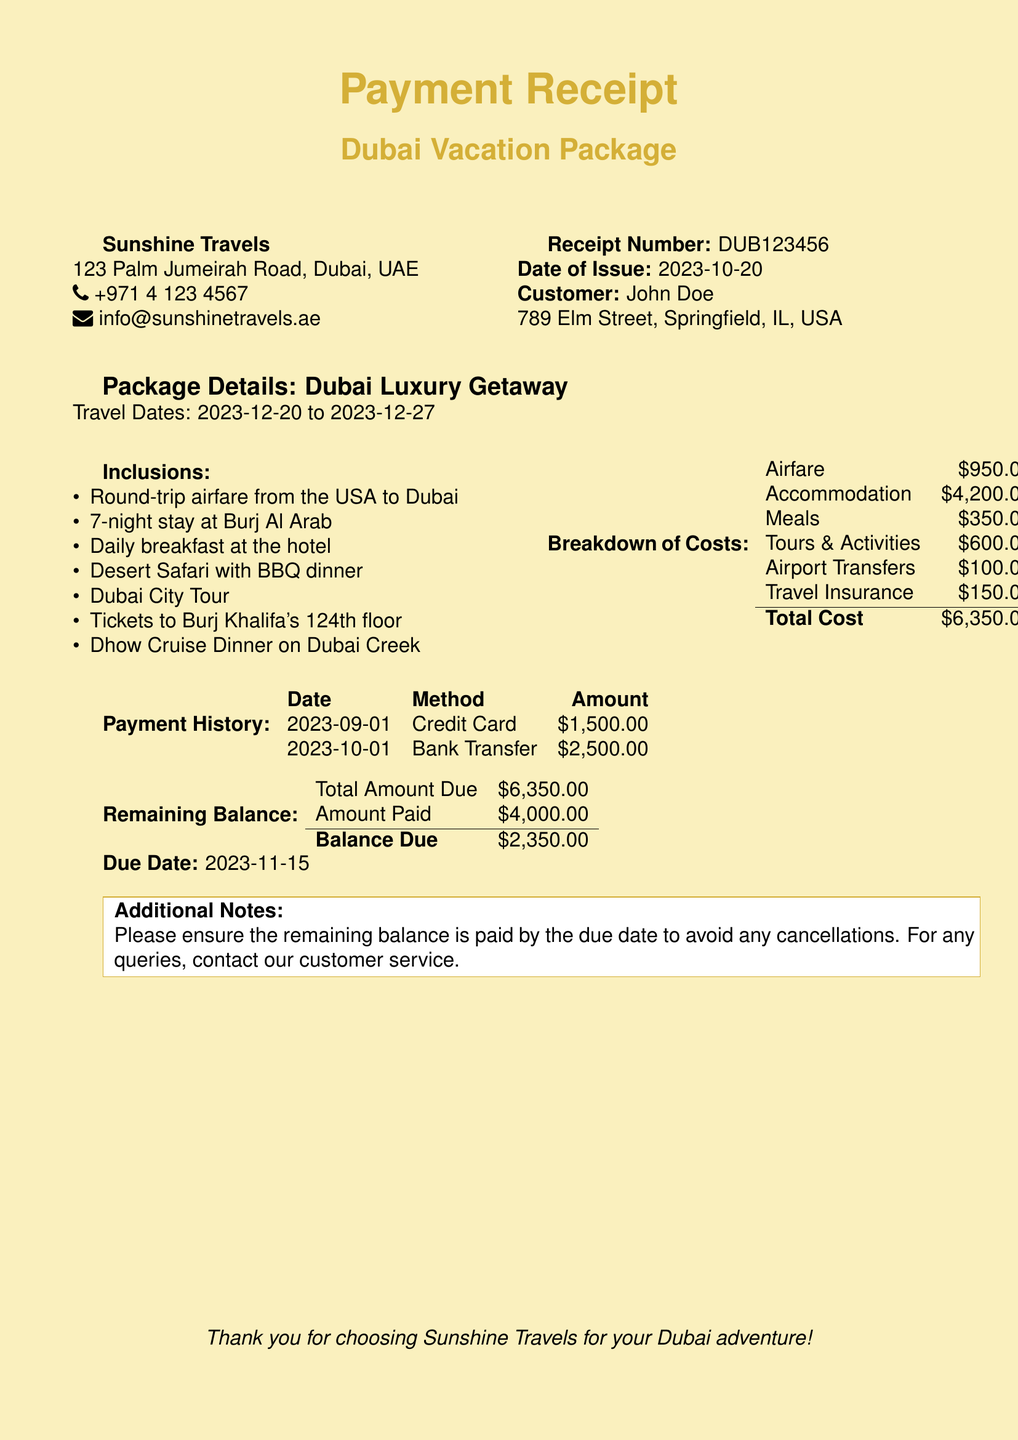What is the receipt number? The receipt number is listed in the document for tracking purposes, which is DUB123456.
Answer: DUB123456 What is the travel date range? The travel dates are specified in the package details, which shows the trip is from 2023-12-20 to 2023-12-27.
Answer: 2023-12-20 to 2023-12-27 What is the total cost of the vacation package? The total cost is summarized in the breakdown of costs section, which sums up to $6,350.00.
Answer: $6,350.00 How much has been paid so far? The payment history lists the amounts that have been paid, which totals $4,000.00.
Answer: $4,000.00 What is the balance due? The balance due is calculated by subtracting the amount paid from the total amount due, which is $2,350.00.
Answer: $2,350.00 What is the due date for the remaining balance? The due date is clearly stated in the document as 2023-11-15.
Answer: 2023-11-15 How many nights is the hotel stay? The duration of the stay at the hotel is mentioned as 7 nights.
Answer: 7 nights What activities are included in the package? The inclusions section lists several activities, including the Desert Safari with BBQ dinner.
Answer: Desert Safari with BBQ dinner Who is the customer for this receipt? The customer information is provided in the document, which names John Doe.
Answer: John Doe 